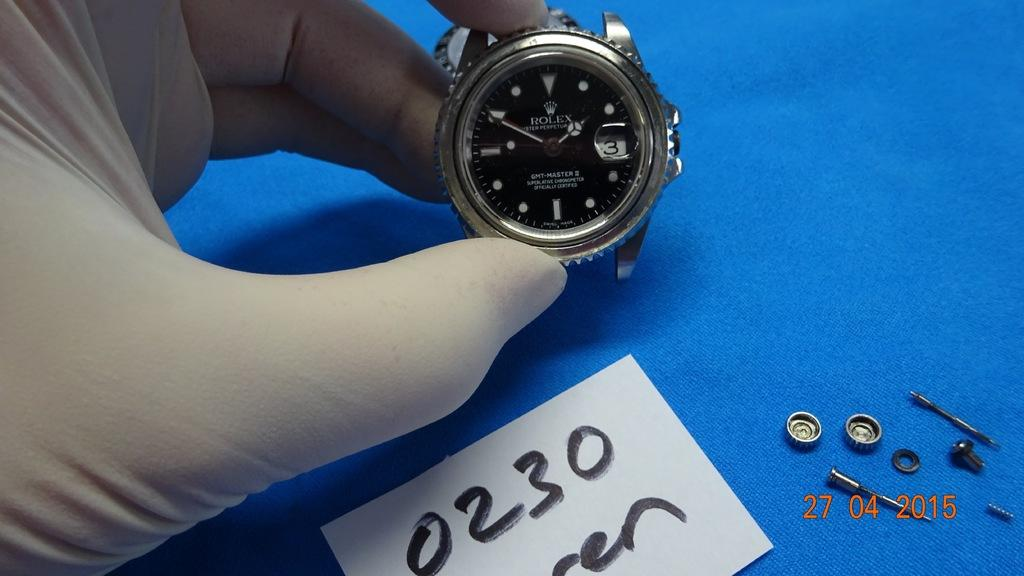<image>
Share a concise interpretation of the image provided. A sign reading  "0230" is next to a watch held in someone's hand. 